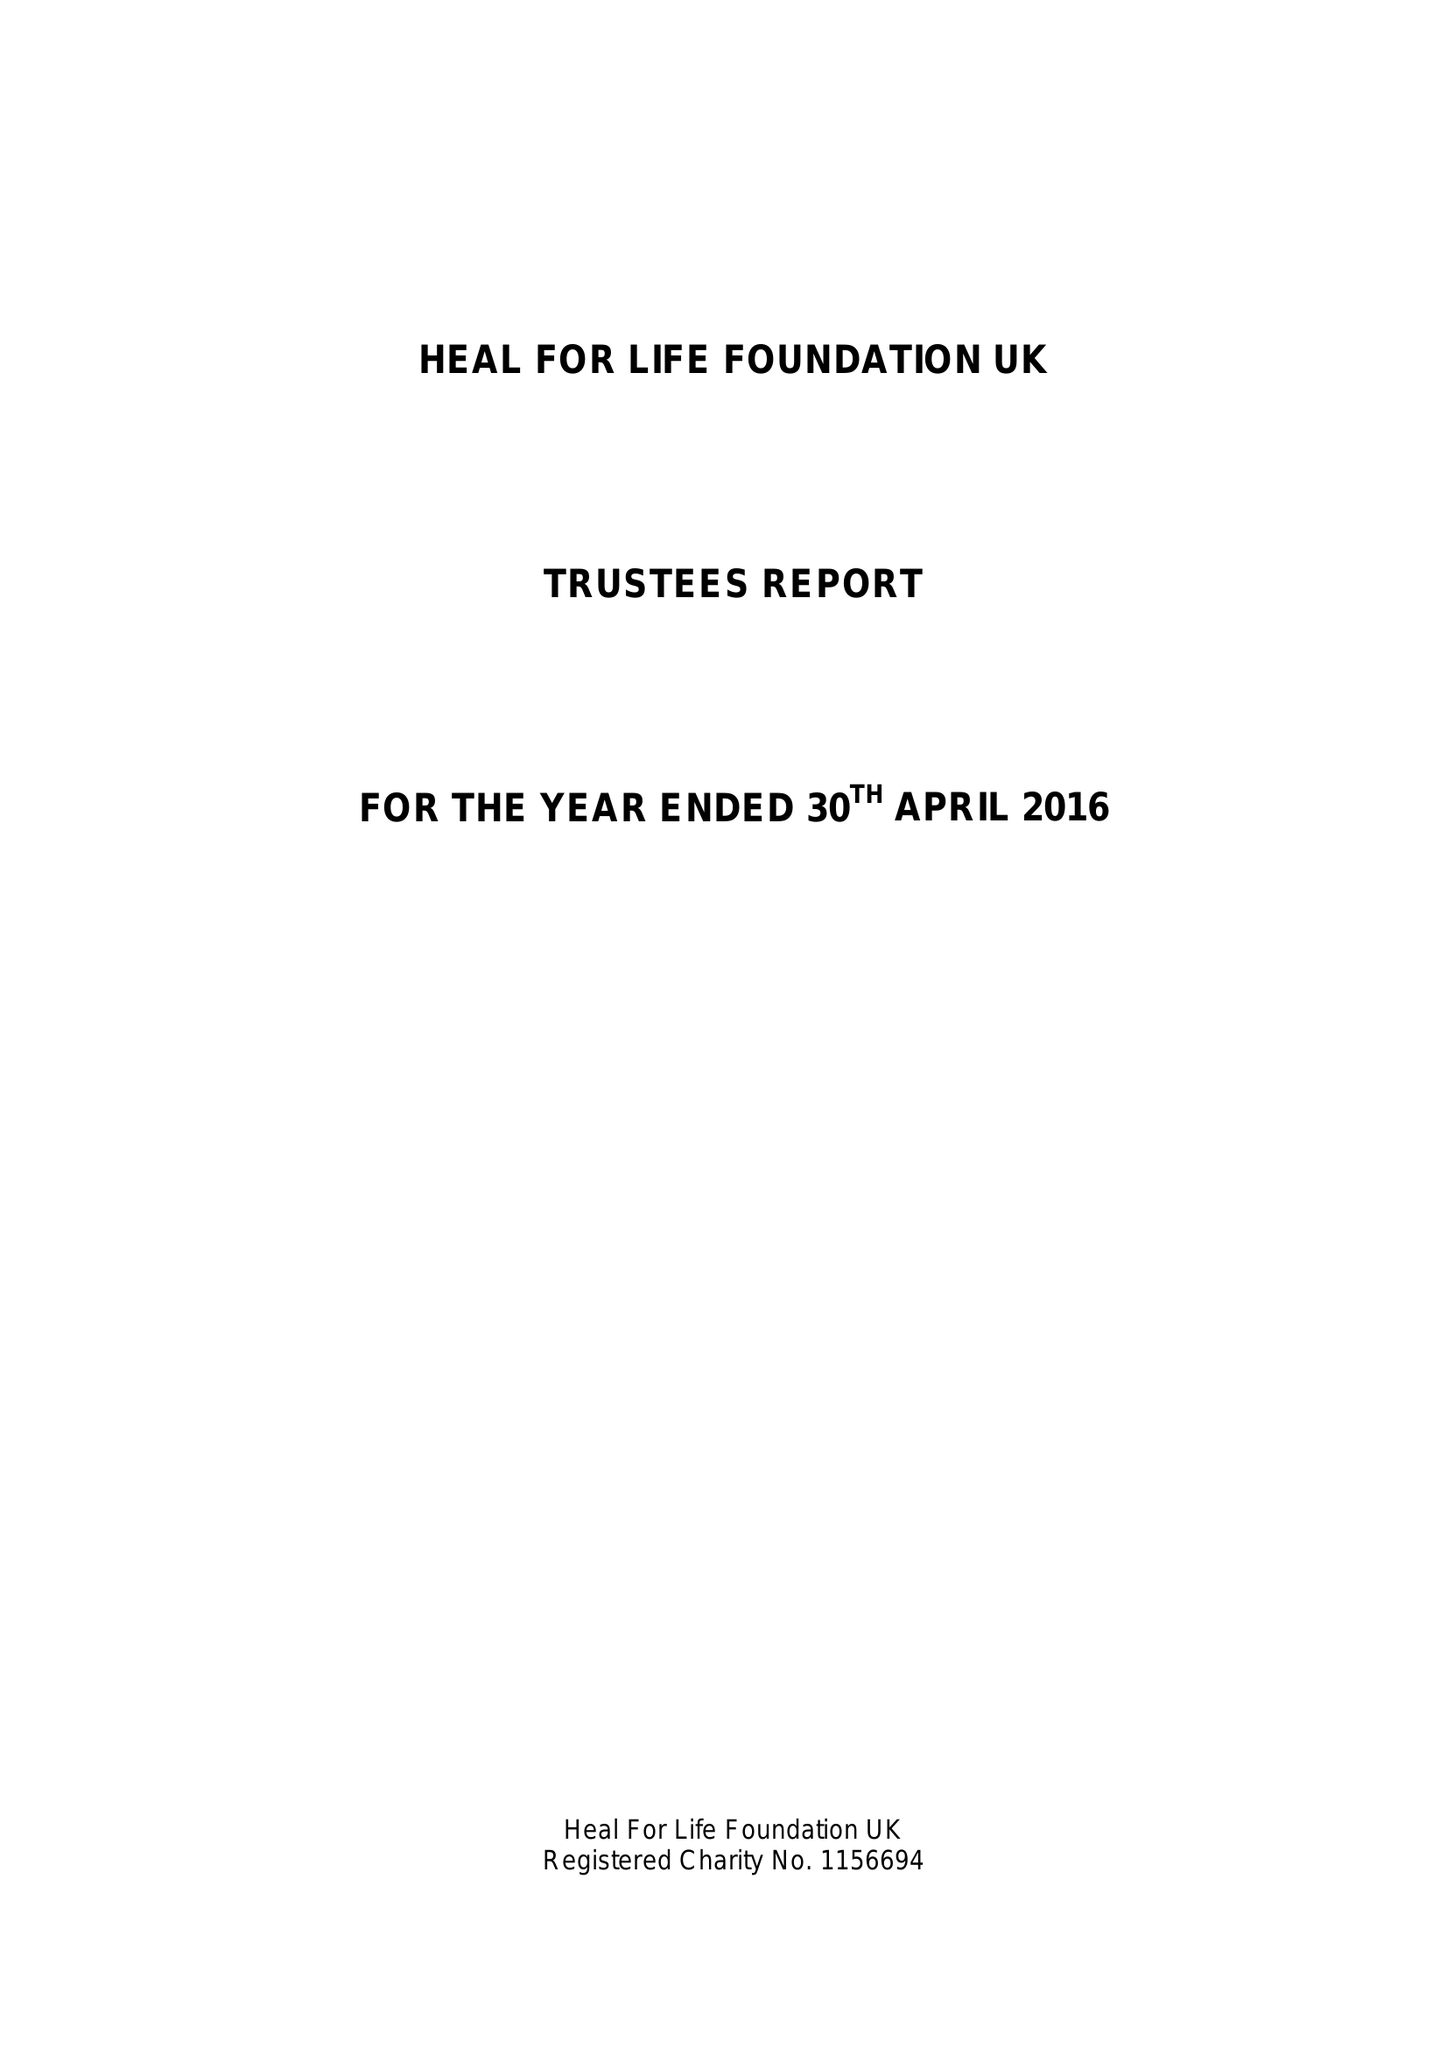What is the value for the income_annually_in_british_pounds?
Answer the question using a single word or phrase. 13921.31 